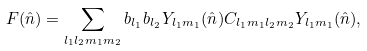Convert formula to latex. <formula><loc_0><loc_0><loc_500><loc_500>F ( \hat { n } ) = \sum _ { l _ { 1 } l _ { 2 } m _ { 1 } m _ { 2 } } b _ { l _ { 1 } } b _ { l _ { 2 } } Y _ { l _ { 1 } m _ { 1 } } ( \hat { n } ) C _ { l _ { 1 } m _ { 1 } l _ { 2 } m _ { 2 } } Y _ { l _ { 1 } m _ { 1 } } ( \hat { n } ) ,</formula> 